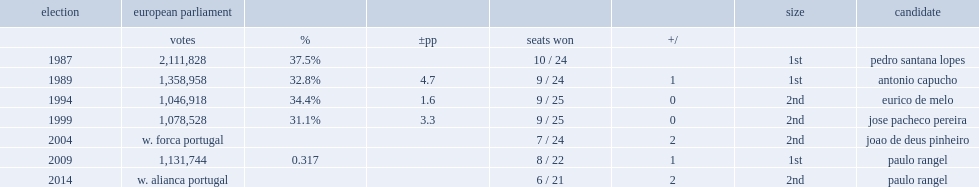In the european parliament election of 2009, how many percent did the psd capture of the popular vote? 0.317. 